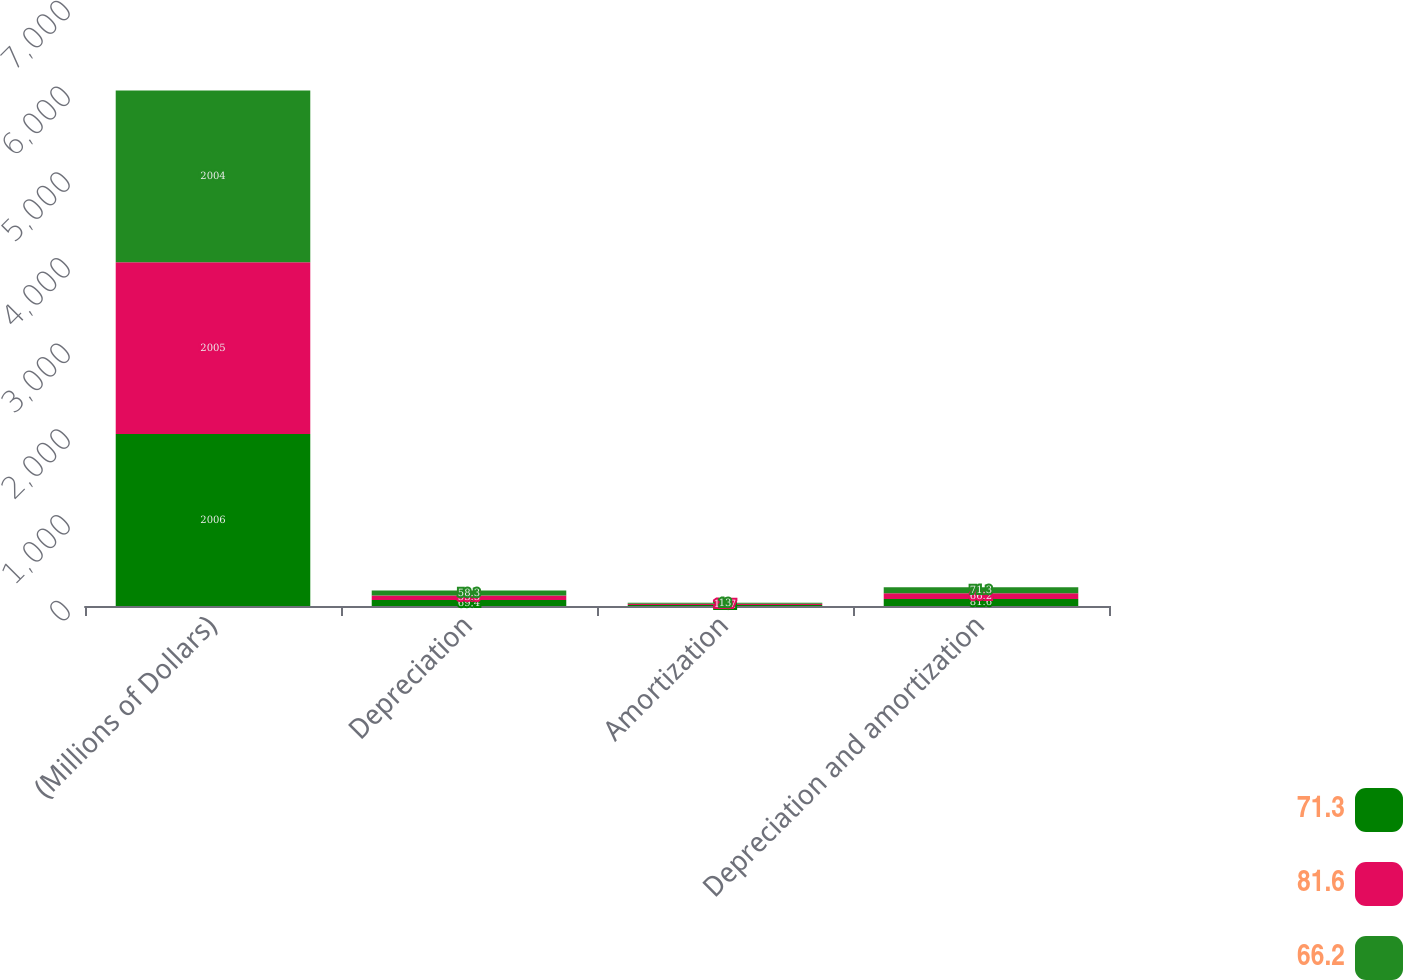Convert chart. <chart><loc_0><loc_0><loc_500><loc_500><stacked_bar_chart><ecel><fcel>(Millions of Dollars)<fcel>Depreciation<fcel>Amortization<fcel>Depreciation and amortization<nl><fcel>71.3<fcel>2006<fcel>69.4<fcel>12.2<fcel>81.6<nl><fcel>81.6<fcel>2005<fcel>53.5<fcel>12.7<fcel>66.2<nl><fcel>66.2<fcel>2004<fcel>58.3<fcel>13<fcel>71.3<nl></chart> 